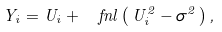Convert formula to latex. <formula><loc_0><loc_0><loc_500><loc_500>Y _ { i } = U _ { i } + \ f n l \left ( \, U _ { i } ^ { 2 } - \sigma ^ { 2 } \, \right ) ,</formula> 